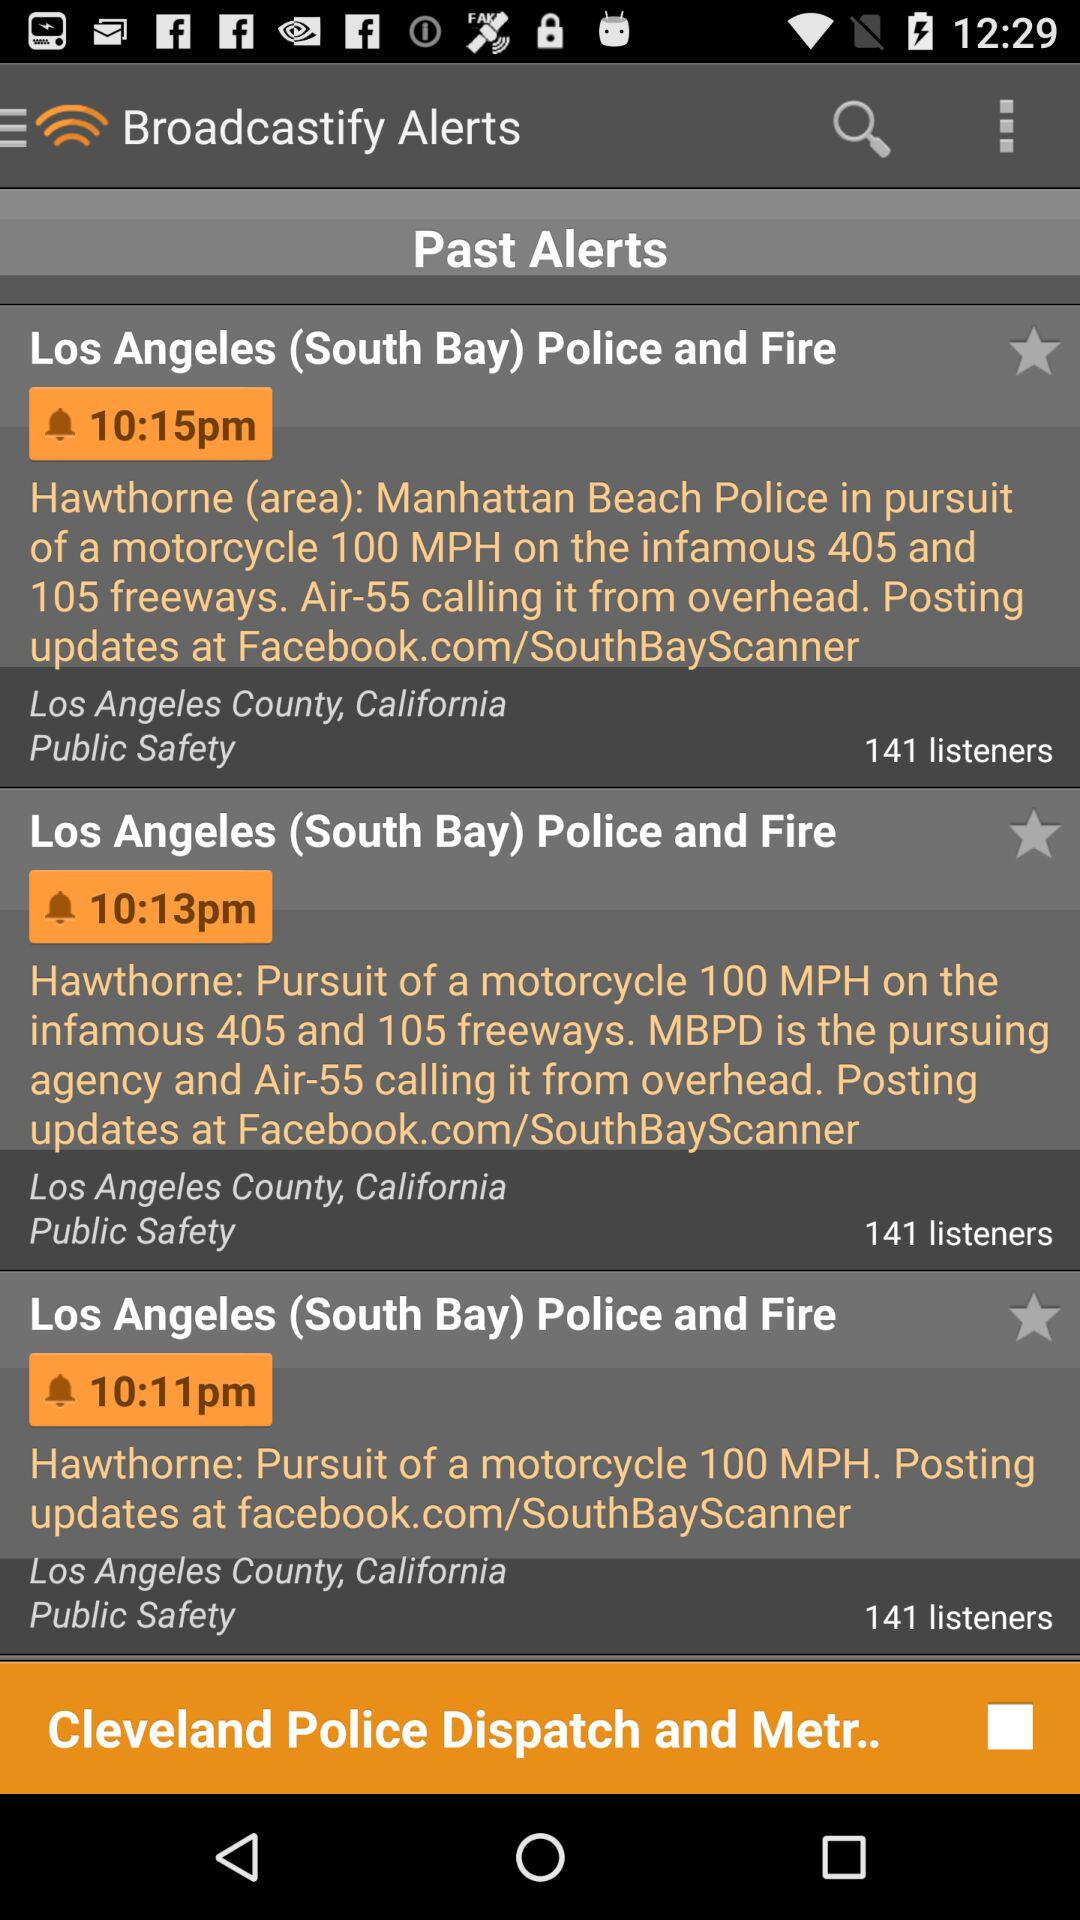What is the headline of the alert broadcast at 10:15 p.m.? The headline of the alert broadcast at 10:15 p.m. is "Los Angeles (South Bay) Police and Fire". 